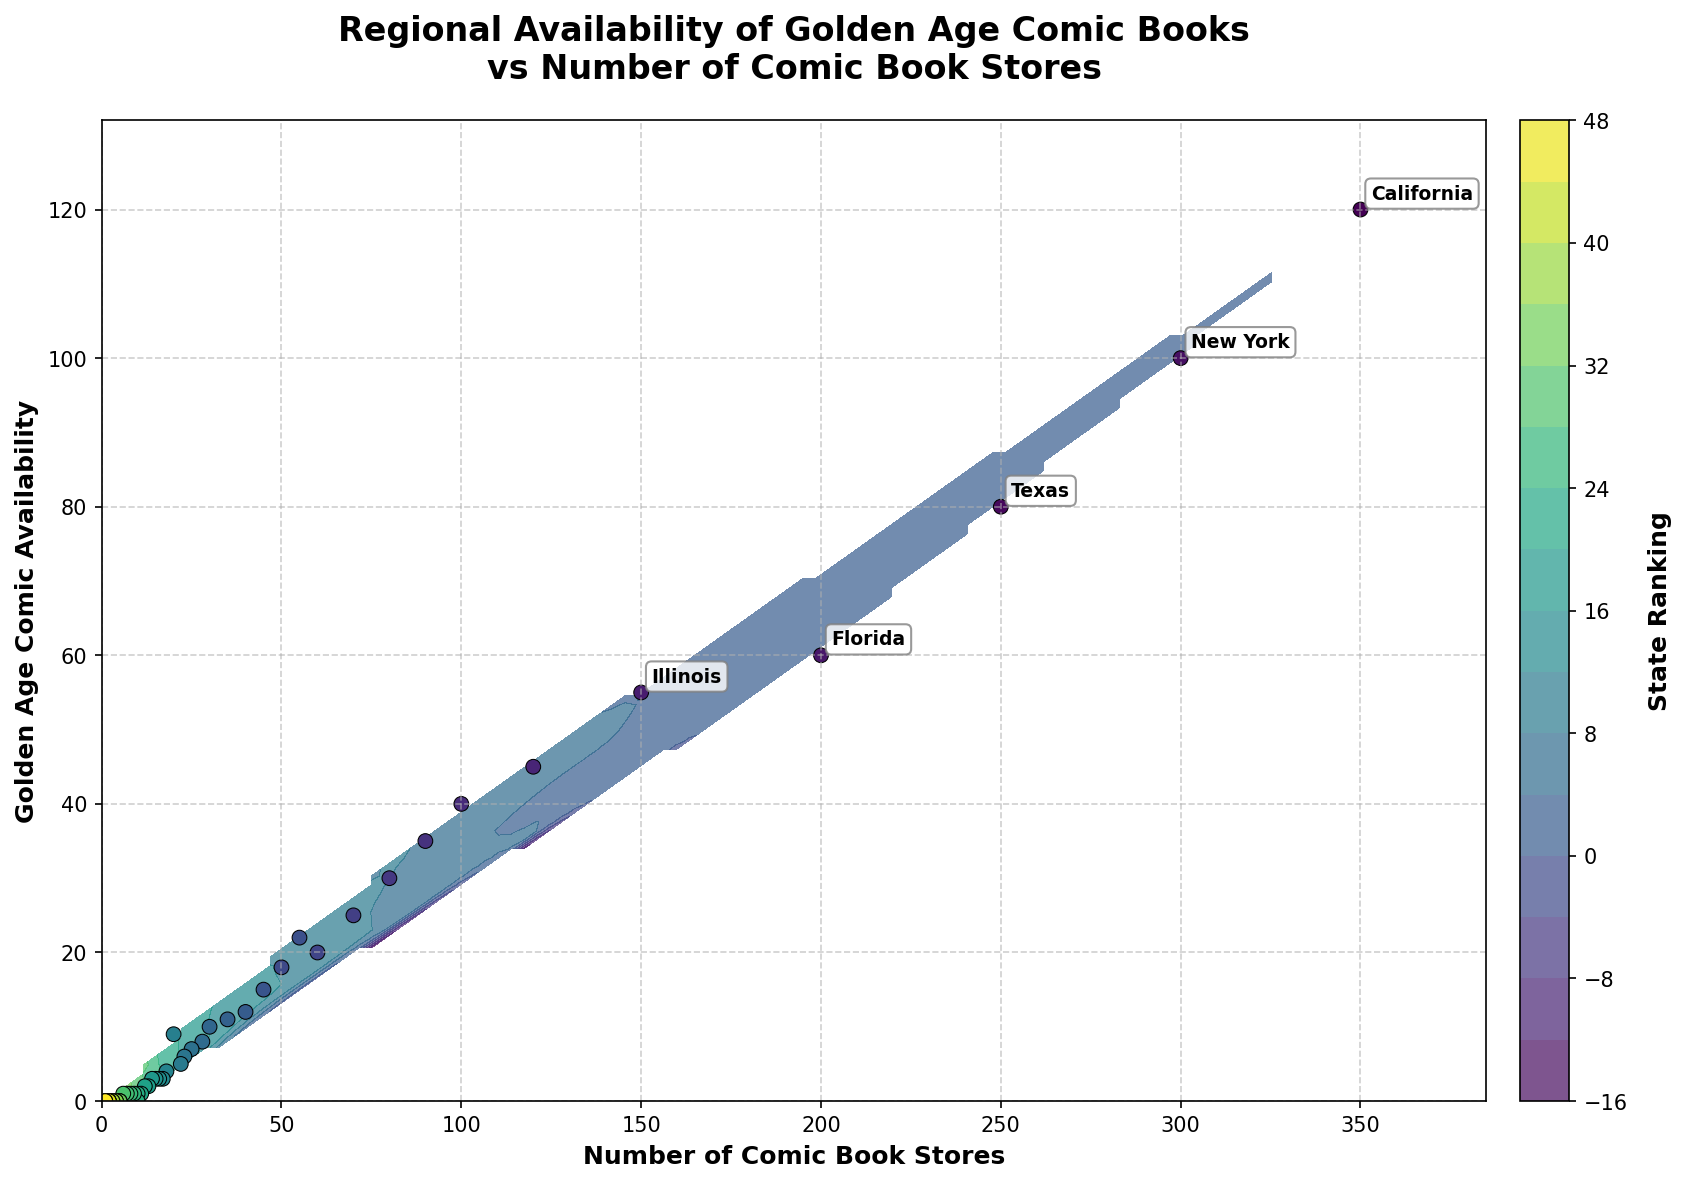How many states are labeled in the plot? The plot annotates the names of the top 5 states with the highest number of comic book stores.
Answer: 5 What is the title of the figure? The figure title is found at the top center of the plot.
Answer: "Regional Availability of Golden Age Comic Books vs Number of Comic Book Stores" Which state has the highest number of comic book stores? The state's name is annotated near the point with the highest x-coordinate. The top 5 states are labeled, and among these, California has the most stores.
Answer: California By how many comic book stores does the state with the second-highest number of stores exceed New York? Find the x-coordinates for the second highest (New York) and the third highest (New York). The annotations are close to the points. The second highest is Texas (250), and the third highest is New York (300). Subtract New York (300) from Texas (250).
Answer: 50 What's the relationship between states' comic book stores and golden age comic availability? The scatter points and contour lines indicate a trend where more comic book stores correspond to higher availability. This can be observed by noting the general upward trend from the lower-left to the upper-right in the plot.
Answer: Positive correlation Estimate the golden age comic availability in a state with approximately 150 comic book stores. Locate the position approximately at x=150 and find the corresponding y-value from the contour or scattered points nearby.
Answer: Around 55 Which state has the lowest number of comic book stores, and what's its golden age comic availability? The state with the fewest stores is indicated by the point with the smallest x-coordinate; check the scales at the lower end.
Answer: Wyoming, 0 How does the number of comic book stores in Illinois compare to that in Ohio? Using the annotations, Illinois has 150 stores and Ohio has 100. Subtract Ohio's value from Illinois's.
Answer: Illinois has 50 more stores than Ohio What do the color gradients in the contour plot represent? The color gradient from dark to light typically represents different levels of state rankings, as indicated by the color bar on the right.
Answer: State ranking levels If a state has no golden age comic books available, what is the maximum number of comic book stores it could have? Check the lowest y-value (y=0) and find the highest corresponding x-coordinate. This will indicate the maximum number of stores with zero availability.
Answer: 10 